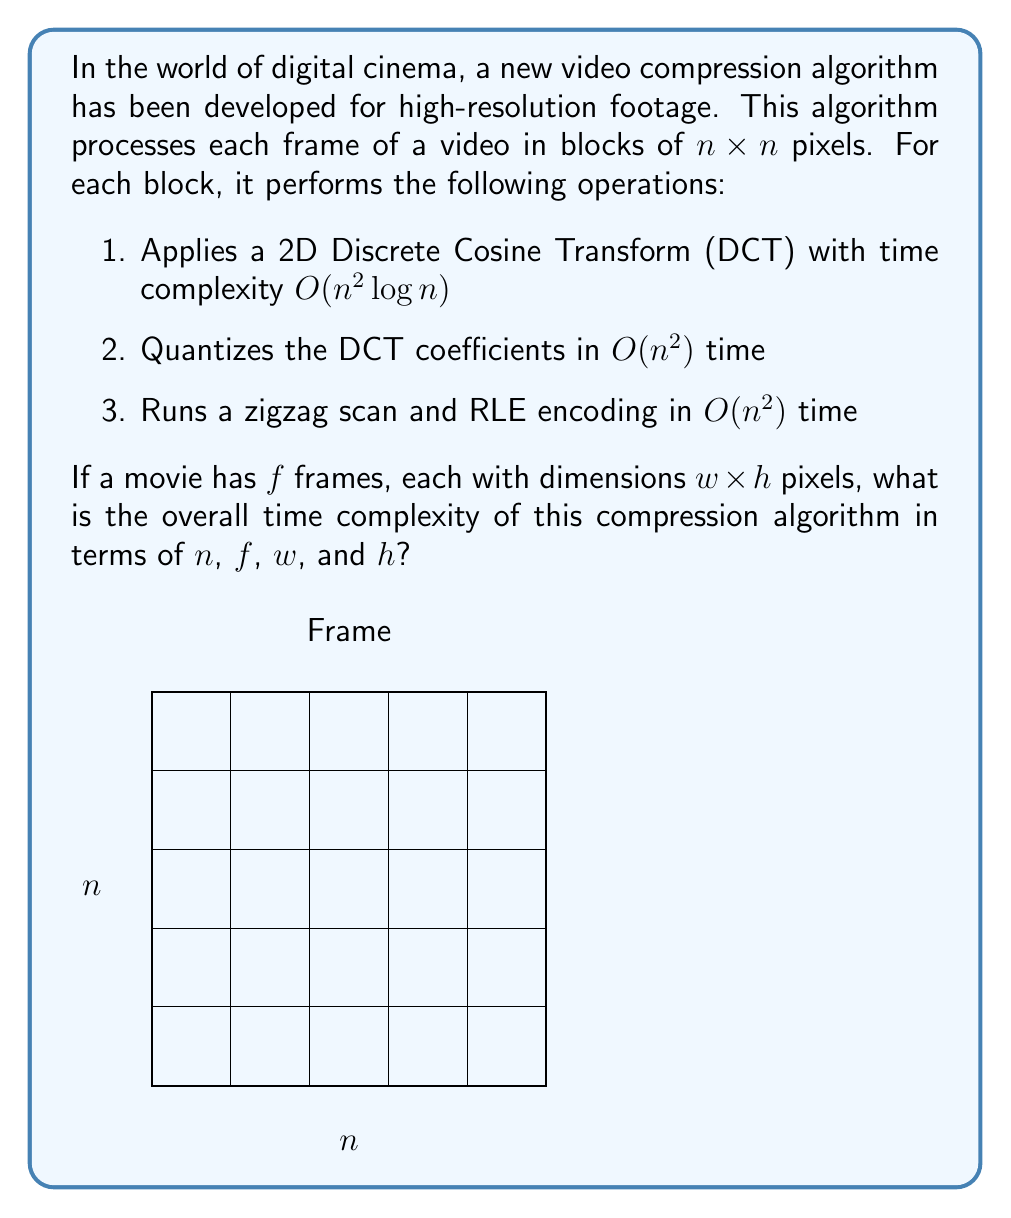Provide a solution to this math problem. Let's break this down step-by-step:

1) First, we need to calculate how many $n \times n$ blocks are in each frame:
   - Each frame has dimensions $w \times h$
   - Number of blocks per frame = $\frac{w}{n} \times \frac{h}{n} = \frac{wh}{n^2}$

2) For each block, the algorithm performs three operations:
   - DCT: $O(n^2 \log n)$
   - Quantization: $O(n^2)$
   - Zigzag scan and RLE: $O(n^2)$

3) The total time for processing one block is:
   $O(n^2 \log n + n^2 + n^2) = O(n^2 \log n)$

4) For each frame, we process $\frac{wh}{n^2}$ blocks, so the time per frame is:
   $O(\frac{wh}{n^2} \times n^2 \log n) = O(wh \log n)$

5) We process $f$ frames in total, so the overall time complexity is:
   $O(f \times wh \log n)$

This represents the time complexity for compressing the entire movie using this algorithm.
Answer: $O(fwh \log n)$ 